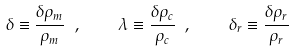<formula> <loc_0><loc_0><loc_500><loc_500>\delta \equiv \frac { \delta \rho _ { m } } { \rho _ { m } } \ , \quad \lambda \equiv \frac { \delta \rho _ { c } } { \rho _ { c } } \ , \quad \delta _ { r } \equiv \frac { \delta \rho _ { r } } { \rho _ { r } } \</formula> 